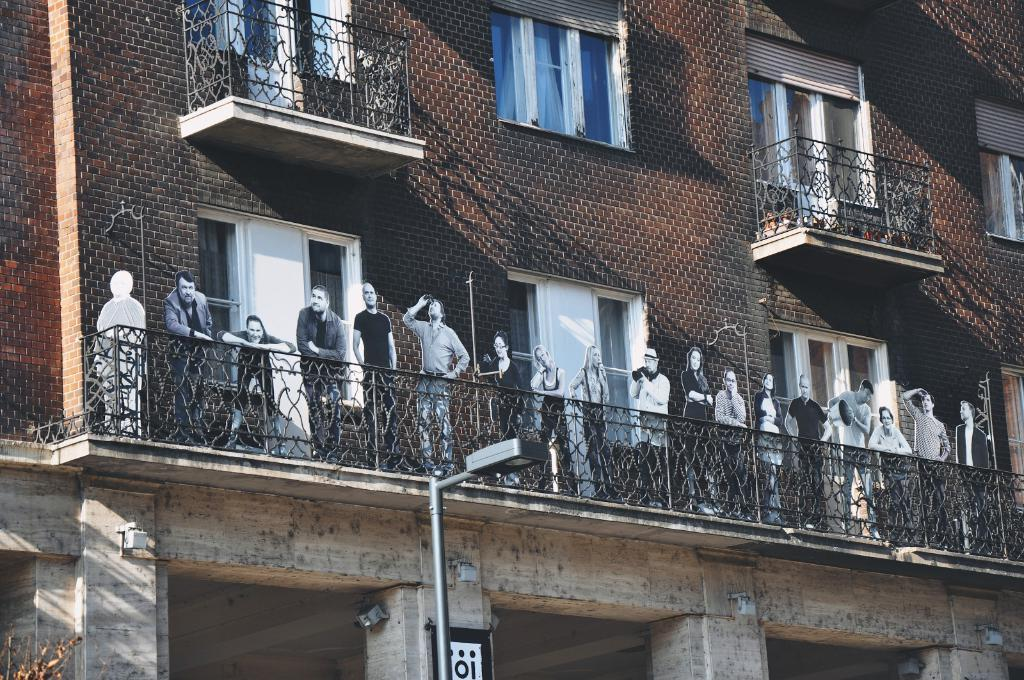What is the main structure in the picture? There is a building in the picture. What decorative elements are present on the building? There are cutouts of people on the building. What type of windows are present on the building? There are many glass windows present on the building. What other object can be seen in the picture? There is a pole with a light in the picture. What type of straw is used to stir the ship in the picture? There is no ship or straw present in the picture; it features a building with cutouts of people and glass windows. 